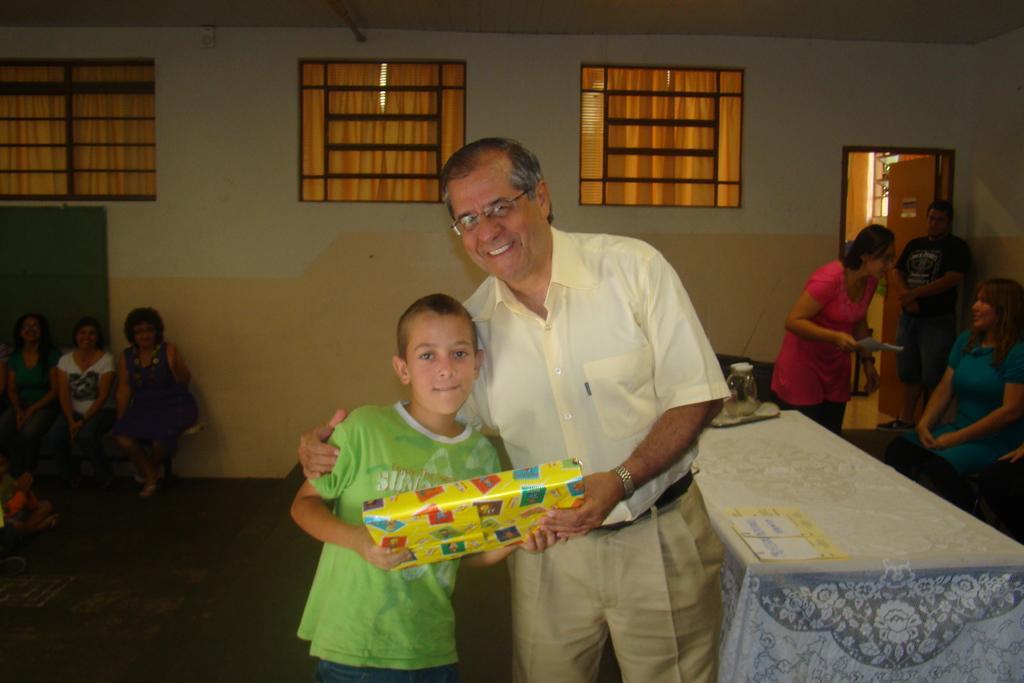Can you describe this image briefly? In this image, there are a few people. We can see the ground and a table covered with a cloth with some objects. We can see the wall with windows and a door. We can also see the board. We can see the roof. 